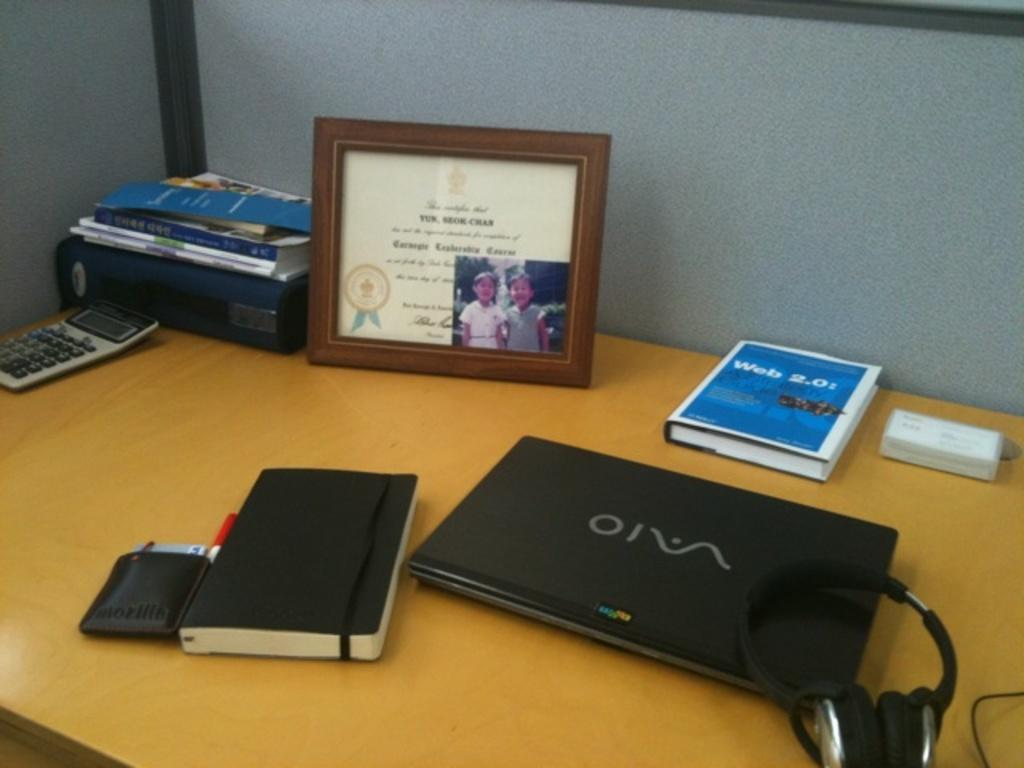<image>
Render a clear and concise summary of the photo. A desk with a diploma on it and a laptop with the name Vaio written on it. 